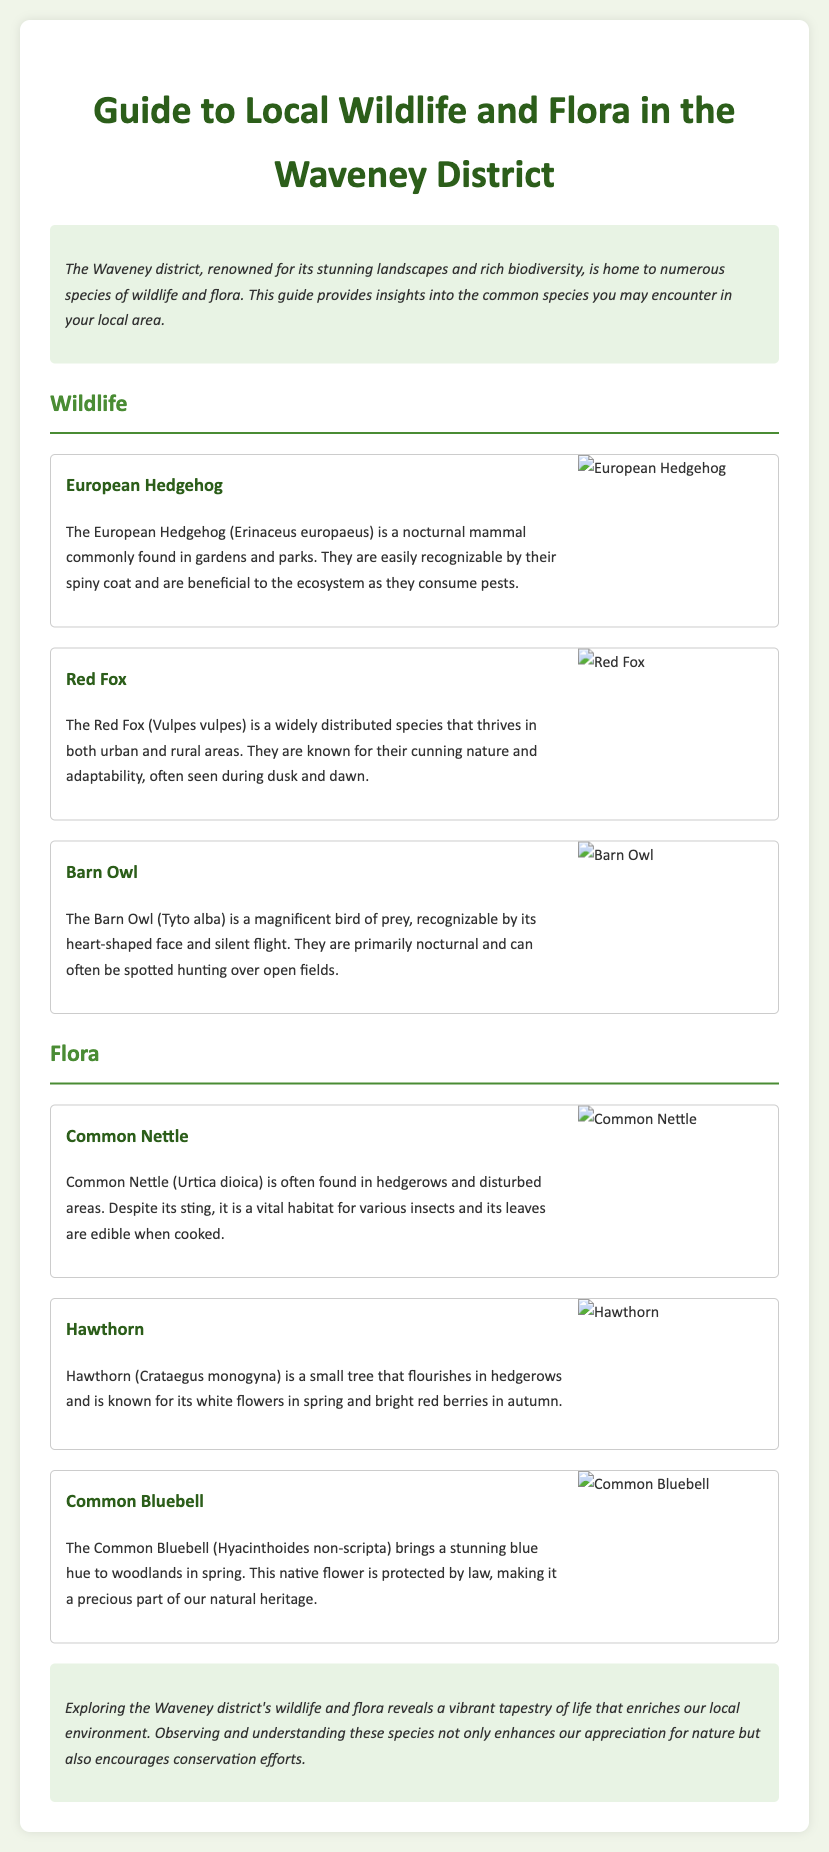What species is commonly found in gardens and parks? The document specifically mentions the European Hedgehog as commonly found in gardens and parks.
Answer: European Hedgehog What is the scientific name of the Red Fox? The Red Fox is listed in the document with its scientific name, Vulpes vulpes.
Answer: Vulpes vulpes Which bird is known for its heart-shaped face? The Barn Owl is described in the document as recognizable by its heart-shaped face.
Answer: Barn Owl What is a common use for the leaves of the Common Nettle? The document states that the leaves of Common Nettle are edible when cooked.
Answer: Edible What color do Common Bluebells bring to woodlands in spring? The guide mentions that Common Bluebells bring a stunning blue hue to woodlands in spring.
Answer: Blue How many wildlife species are listed in the document? There are three wildlife species detailed in the document: European Hedgehog, Red Fox, and Barn Owl.
Answer: Three Which tree is known for its white flowers in spring? The document indicates that Hawthorn is known for its white flowers in spring.
Answer: Hawthorn Which species is protected by law? The Common Bluebell is mentioned in the document as being protected by law.
Answer: Common Bluebell In what type of areas is Common Nettle commonly found? The document states that Common Nettle is often found in hedgerows and disturbed areas.
Answer: Hedgerows and disturbed areas 